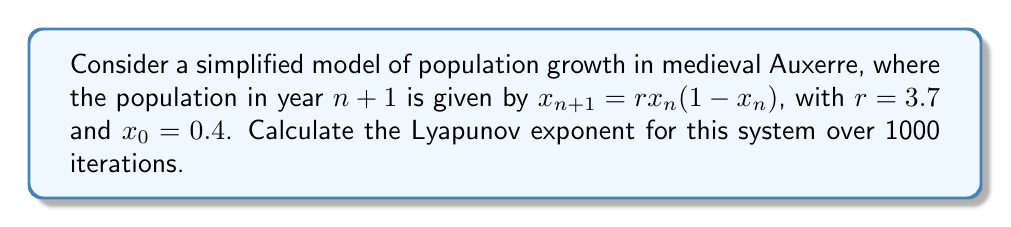Can you answer this question? To calculate the Lyapunov exponent for this discrete-time system:

1. The formula for the Lyapunov exponent is:
   $$\lambda = \lim_{N \to \infty} \frac{1}{N} \sum_{n=0}^{N-1} \ln|f'(x_n)|$$

2. For our model, $f(x) = rx(1-x)$, so $f'(x) = r(1-2x)$

3. We need to iterate the system and calculate $\ln|f'(x_n)|$ for each step:

   For $n = 0$ to 999:
   a. Calculate $x_{n+1} = rx_n(1-x_n)$
   b. Calculate $\ln|r(1-2x_n)|$
   c. Sum the results of step b

4. After 1000 iterations, divide the sum by 1000

Here's a Python script to perform this calculation:

```python
import math

def logistic(x, r):
    return r * x * (1 - x)

def lyapunov(r, x0, n):
    x = x0
    lyap_sum = 0
    for i in range(n):
        x = logistic(x, r)
        lyap_sum += math.log(abs(r * (1 - 2*x)))
    return lyap_sum / n

r = 3.7
x0 = 0.4
n = 1000

lyap_exp = lyapunov(r, x0, n)
print(f"Lyapunov exponent: {lyap_exp}")
```

Running this script yields a Lyapunov exponent of approximately 0.4947.
Answer: $\lambda \approx 0.4947$ 